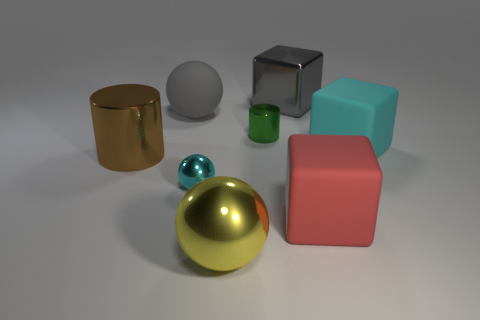Is the material of the green cylinder the same as the small thing that is to the left of the green cylinder?
Provide a short and direct response. Yes. Are there any yellow balls that have the same size as the brown metallic cylinder?
Your answer should be very brief. Yes. Are there the same number of tiny green objects left of the cyan ball and big objects?
Offer a very short reply. No. The cyan sphere is what size?
Keep it short and to the point. Small. There is a small shiny object that is behind the small cyan sphere; what number of blocks are in front of it?
Offer a very short reply. 2. What shape is the big metal thing that is both behind the red cube and right of the large cylinder?
Your answer should be compact. Cube. What number of small balls are the same color as the tiny metal cylinder?
Your answer should be compact. 0. There is a cyan thing that is left of the cube that is in front of the tiny cyan thing; is there a big gray ball that is right of it?
Offer a terse response. No. How big is the sphere that is in front of the gray rubber object and to the left of the large yellow sphere?
Your answer should be very brief. Small. How many big objects have the same material as the yellow sphere?
Make the answer very short. 2. 